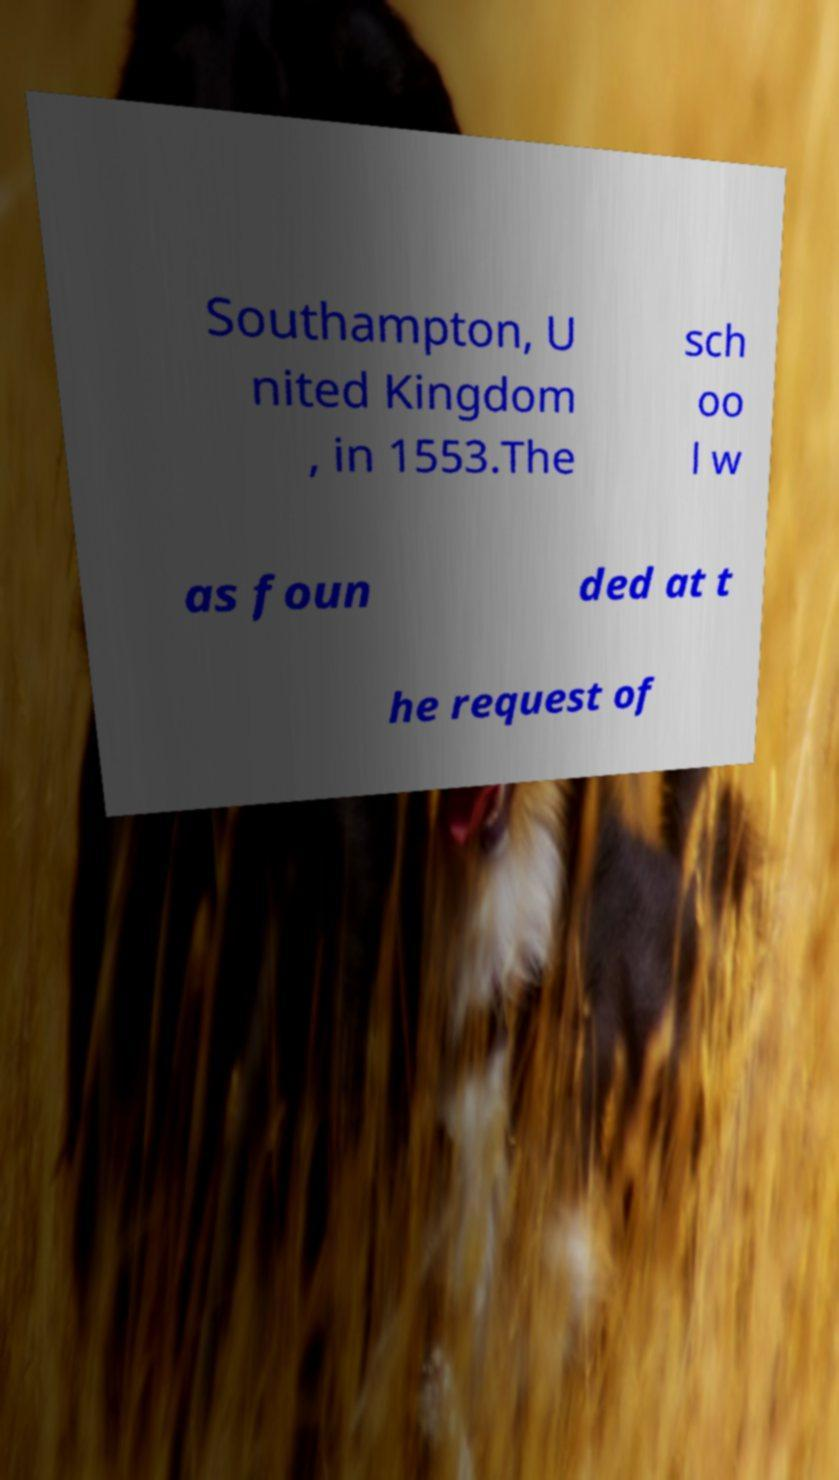Please identify and transcribe the text found in this image. Southampton, U nited Kingdom , in 1553.The sch oo l w as foun ded at t he request of 